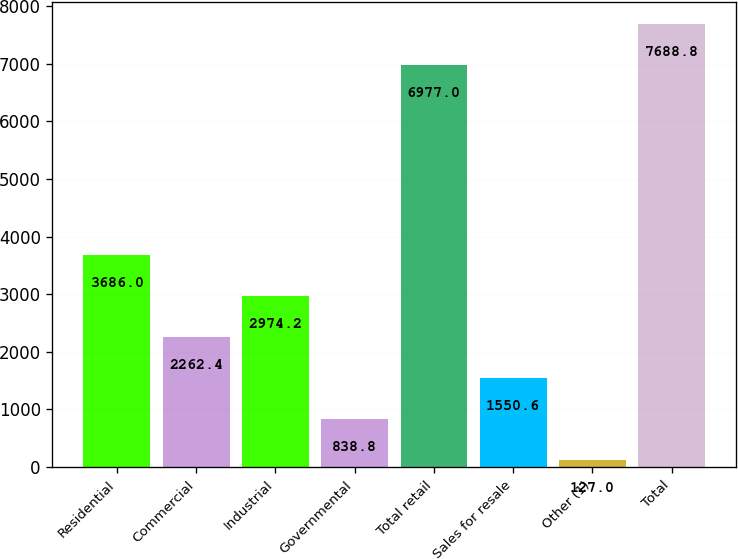<chart> <loc_0><loc_0><loc_500><loc_500><bar_chart><fcel>Residential<fcel>Commercial<fcel>Industrial<fcel>Governmental<fcel>Total retail<fcel>Sales for resale<fcel>Other (1)<fcel>Total<nl><fcel>3686<fcel>2262.4<fcel>2974.2<fcel>838.8<fcel>6977<fcel>1550.6<fcel>127<fcel>7688.8<nl></chart> 